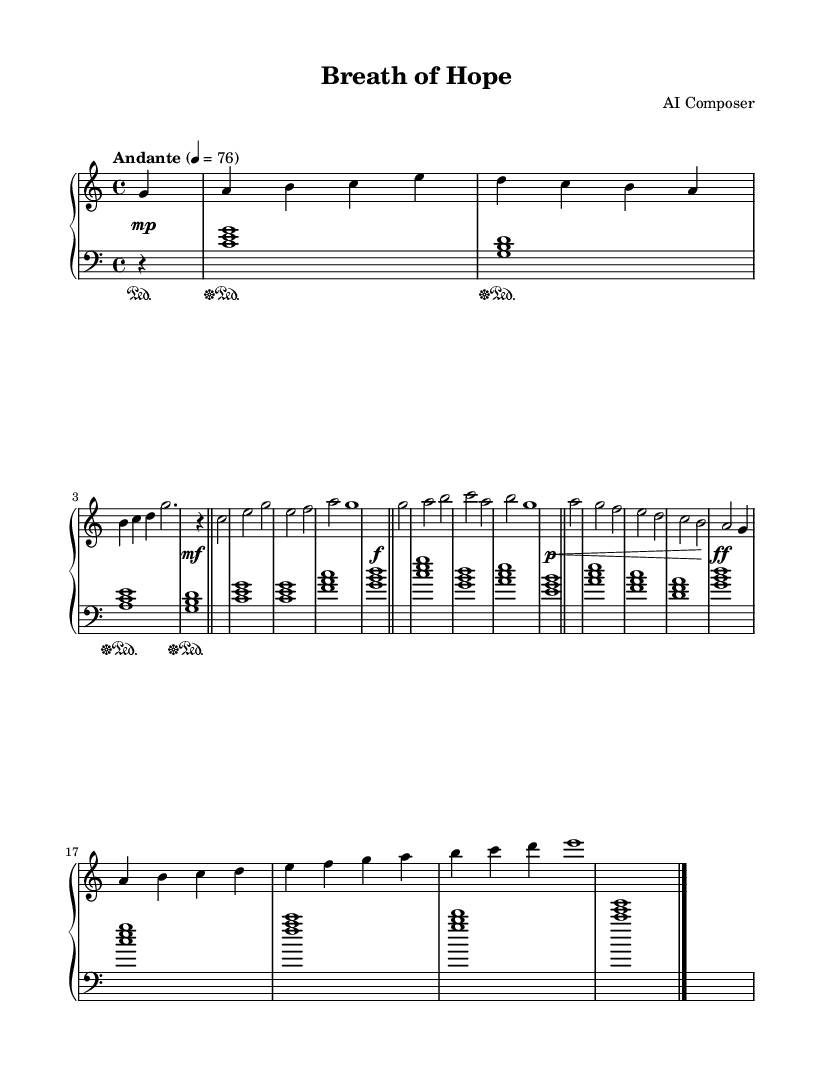What is the key signature of this music? The key signature is indicated at the beginning of the sheet music, showing there are no sharps or flats present, which corresponds to C major.
Answer: C major What is the time signature of this music? The time signature is displayed at the beginning of the piece, showing the division of beats in each measure as 4 beats per measure, which is represented as 4/4.
Answer: 4/4 What is the tempo marking for this piece? The tempo marking appears at the beginning of the piece, denoted by "Andante" and a metronome marking of 76 beats per minute.
Answer: Andante 76 How many measures are there in the bridge section? By counting the measures notated in the bridge section from the sheet music, there are a total of 8 measures present.
Answer: 8 What is the dynamic marking for the final bar? The final bar is represented with a dynamic marking "f", indicating that it should be played loudly (forte).
Answer: f What piano technique is indicated by the pedal markings? The sheet music indicates a pedal technique, shown by the use of "sustainOn" and "sustainOff" markings, allowing for smoother transitions between the notes.
Answer: Sustain 